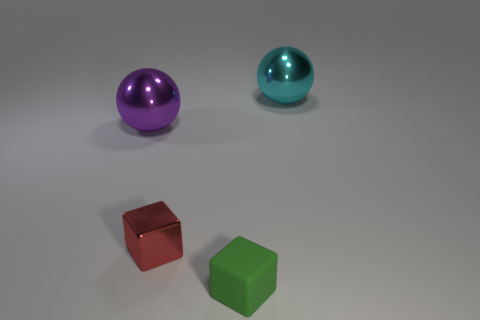Add 4 small shiny things. How many objects exist? 8 Subtract all big gray balls. Subtract all green things. How many objects are left? 3 Add 4 green matte objects. How many green matte objects are left? 5 Add 4 big blue cylinders. How many big blue cylinders exist? 4 Subtract 0 gray cylinders. How many objects are left? 4 